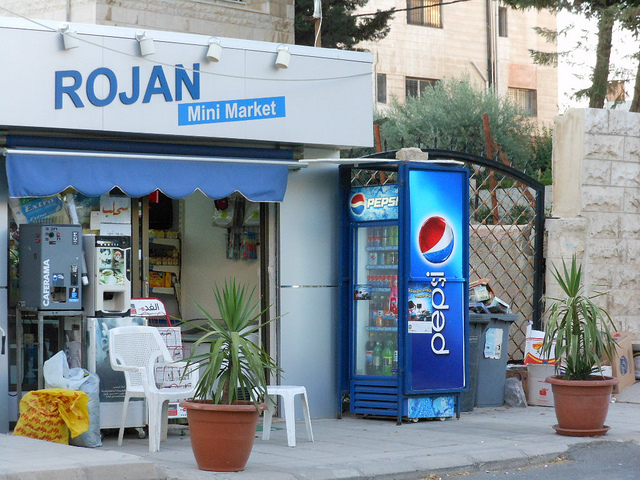Describe the surroundings of the store. The store is situated next to a stone wall with a large tree in the background. There's a residential feel to the area, suggesting that the mini market serves the local community. 